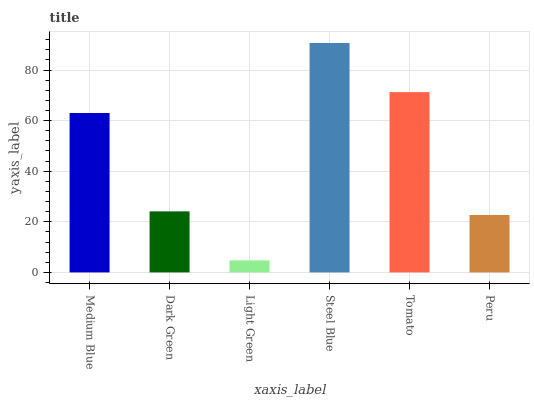Is Light Green the minimum?
Answer yes or no. Yes. Is Steel Blue the maximum?
Answer yes or no. Yes. Is Dark Green the minimum?
Answer yes or no. No. Is Dark Green the maximum?
Answer yes or no. No. Is Medium Blue greater than Dark Green?
Answer yes or no. Yes. Is Dark Green less than Medium Blue?
Answer yes or no. Yes. Is Dark Green greater than Medium Blue?
Answer yes or no. No. Is Medium Blue less than Dark Green?
Answer yes or no. No. Is Medium Blue the high median?
Answer yes or no. Yes. Is Dark Green the low median?
Answer yes or no. Yes. Is Light Green the high median?
Answer yes or no. No. Is Steel Blue the low median?
Answer yes or no. No. 